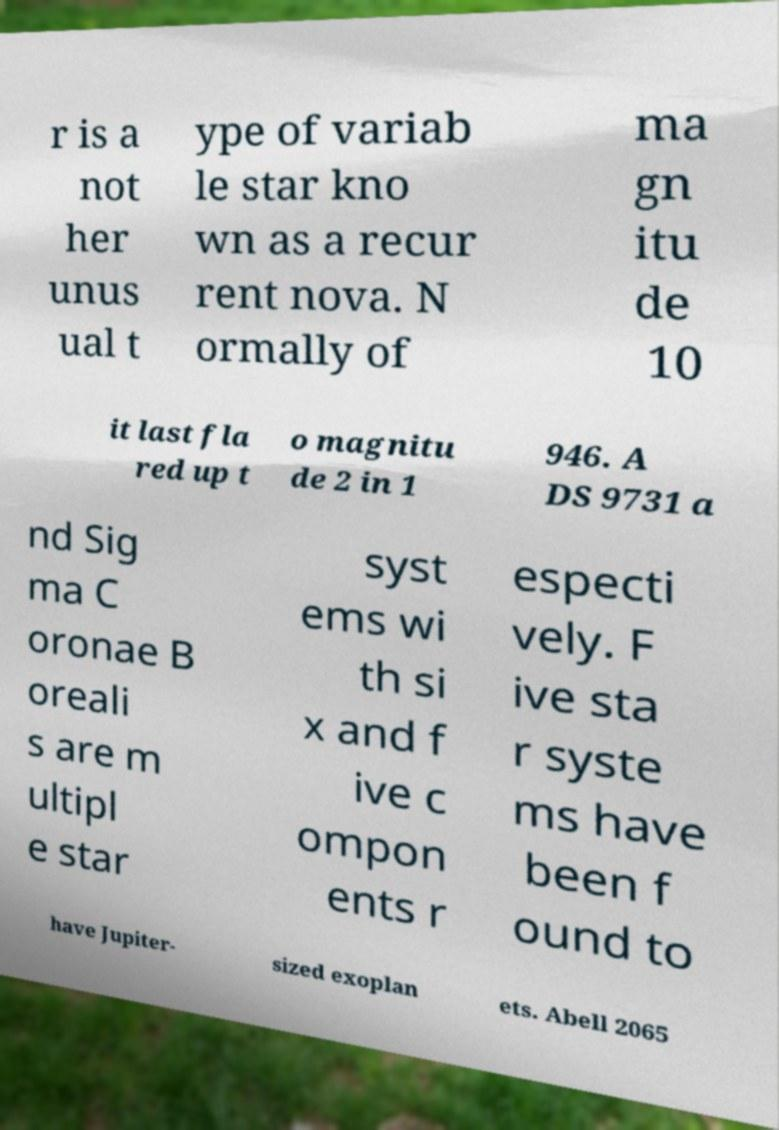Can you accurately transcribe the text from the provided image for me? r is a not her unus ual t ype of variab le star kno wn as a recur rent nova. N ormally of ma gn itu de 10 it last fla red up t o magnitu de 2 in 1 946. A DS 9731 a nd Sig ma C oronae B oreali s are m ultipl e star syst ems wi th si x and f ive c ompon ents r especti vely. F ive sta r syste ms have been f ound to have Jupiter- sized exoplan ets. Abell 2065 